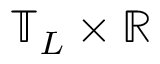Convert formula to latex. <formula><loc_0><loc_0><loc_500><loc_500>\mathbb { T } _ { L } \times \mathbb { R }</formula> 